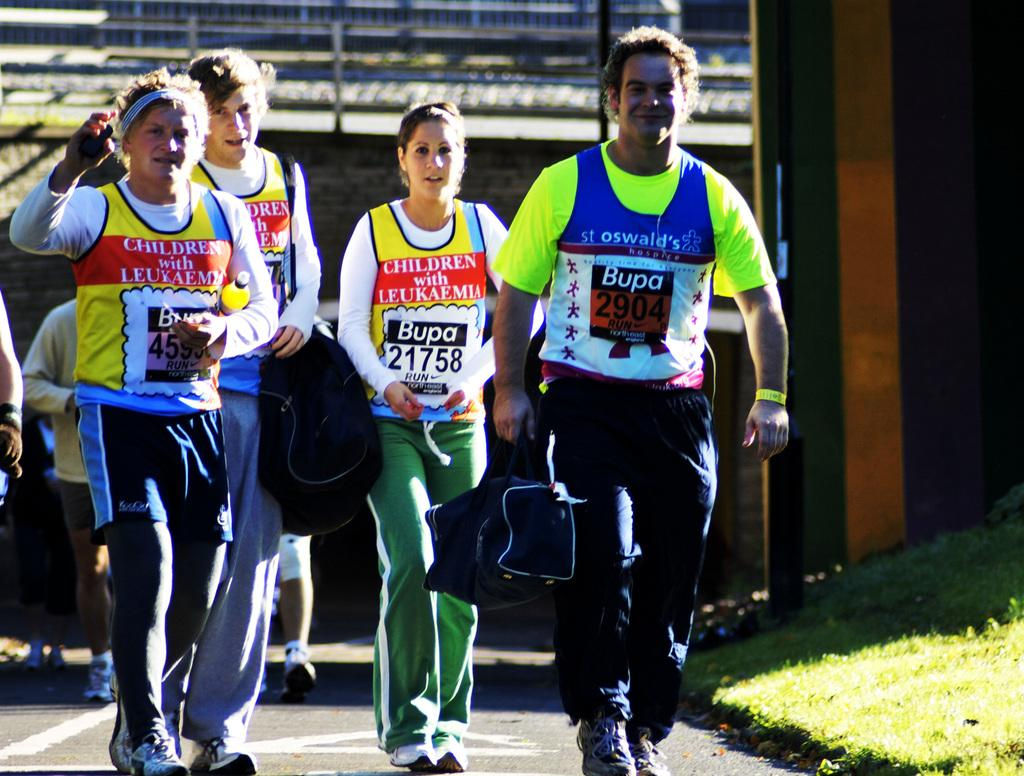<image>
Offer a succinct explanation of the picture presented. a group of people wearing different shirt bibbs from Bupa 